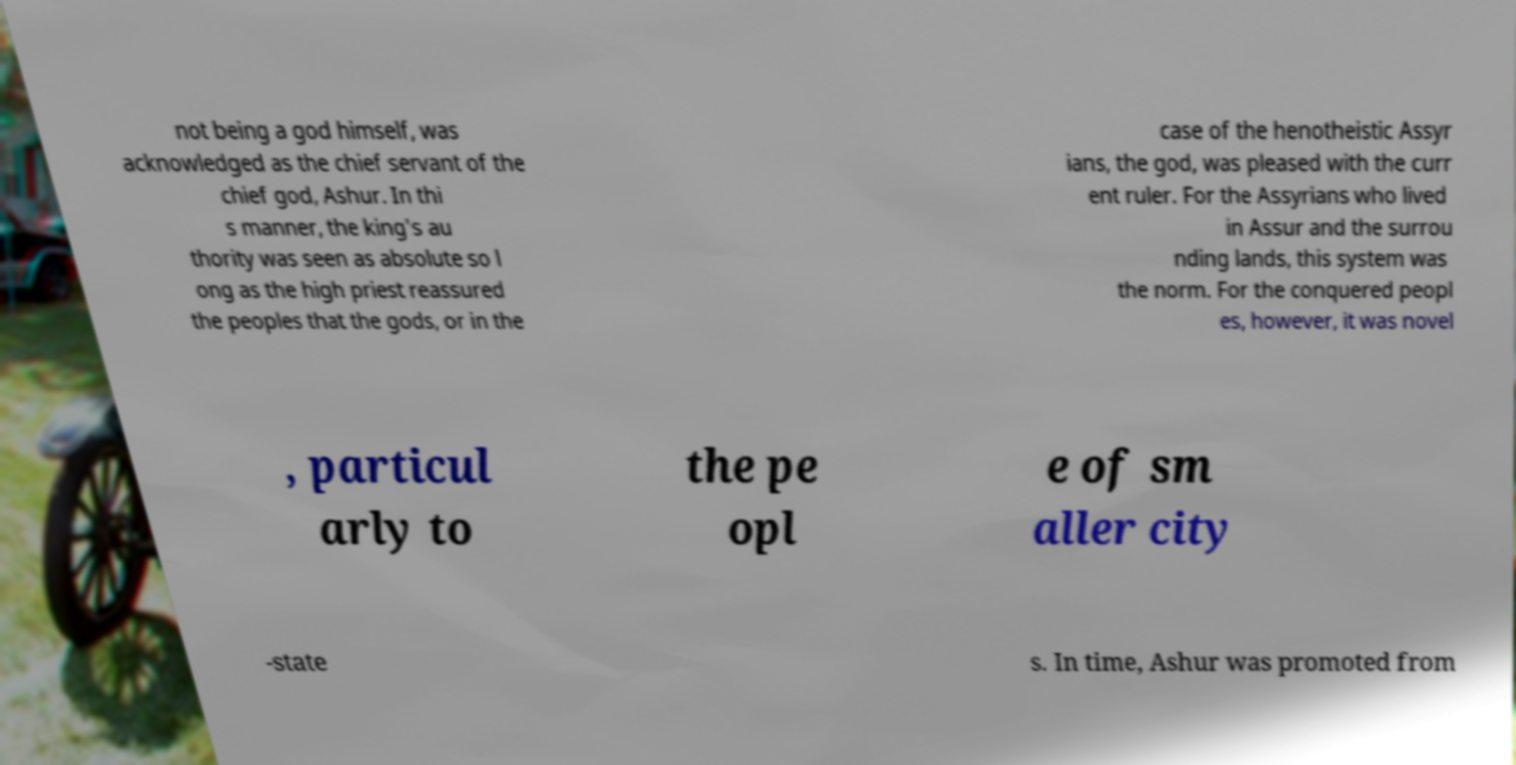What messages or text are displayed in this image? I need them in a readable, typed format. not being a god himself, was acknowledged as the chief servant of the chief god, Ashur. In thi s manner, the king's au thority was seen as absolute so l ong as the high priest reassured the peoples that the gods, or in the case of the henotheistic Assyr ians, the god, was pleased with the curr ent ruler. For the Assyrians who lived in Assur and the surrou nding lands, this system was the norm. For the conquered peopl es, however, it was novel , particul arly to the pe opl e of sm aller city -state s. In time, Ashur was promoted from 